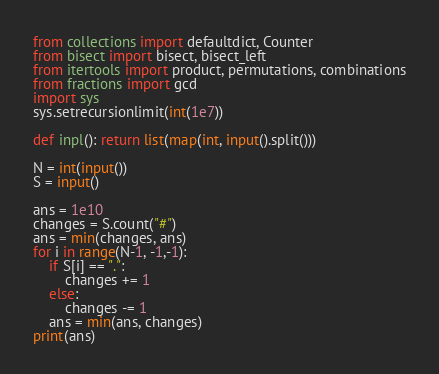Convert code to text. <code><loc_0><loc_0><loc_500><loc_500><_Python_>from collections import defaultdict, Counter
from bisect import bisect, bisect_left
from itertools import product, permutations, combinations
from fractions import gcd
import sys
sys.setrecursionlimit(int(1e7))

def inpl(): return list(map(int, input().split()))

N = int(input())
S = input()

ans = 1e10
changes = S.count("#")
ans = min(changes, ans)
for i in range(N-1, -1,-1):
    if S[i] == ".":
        changes += 1
    else:
        changes -= 1
    ans = min(ans, changes)
print(ans)
</code> 